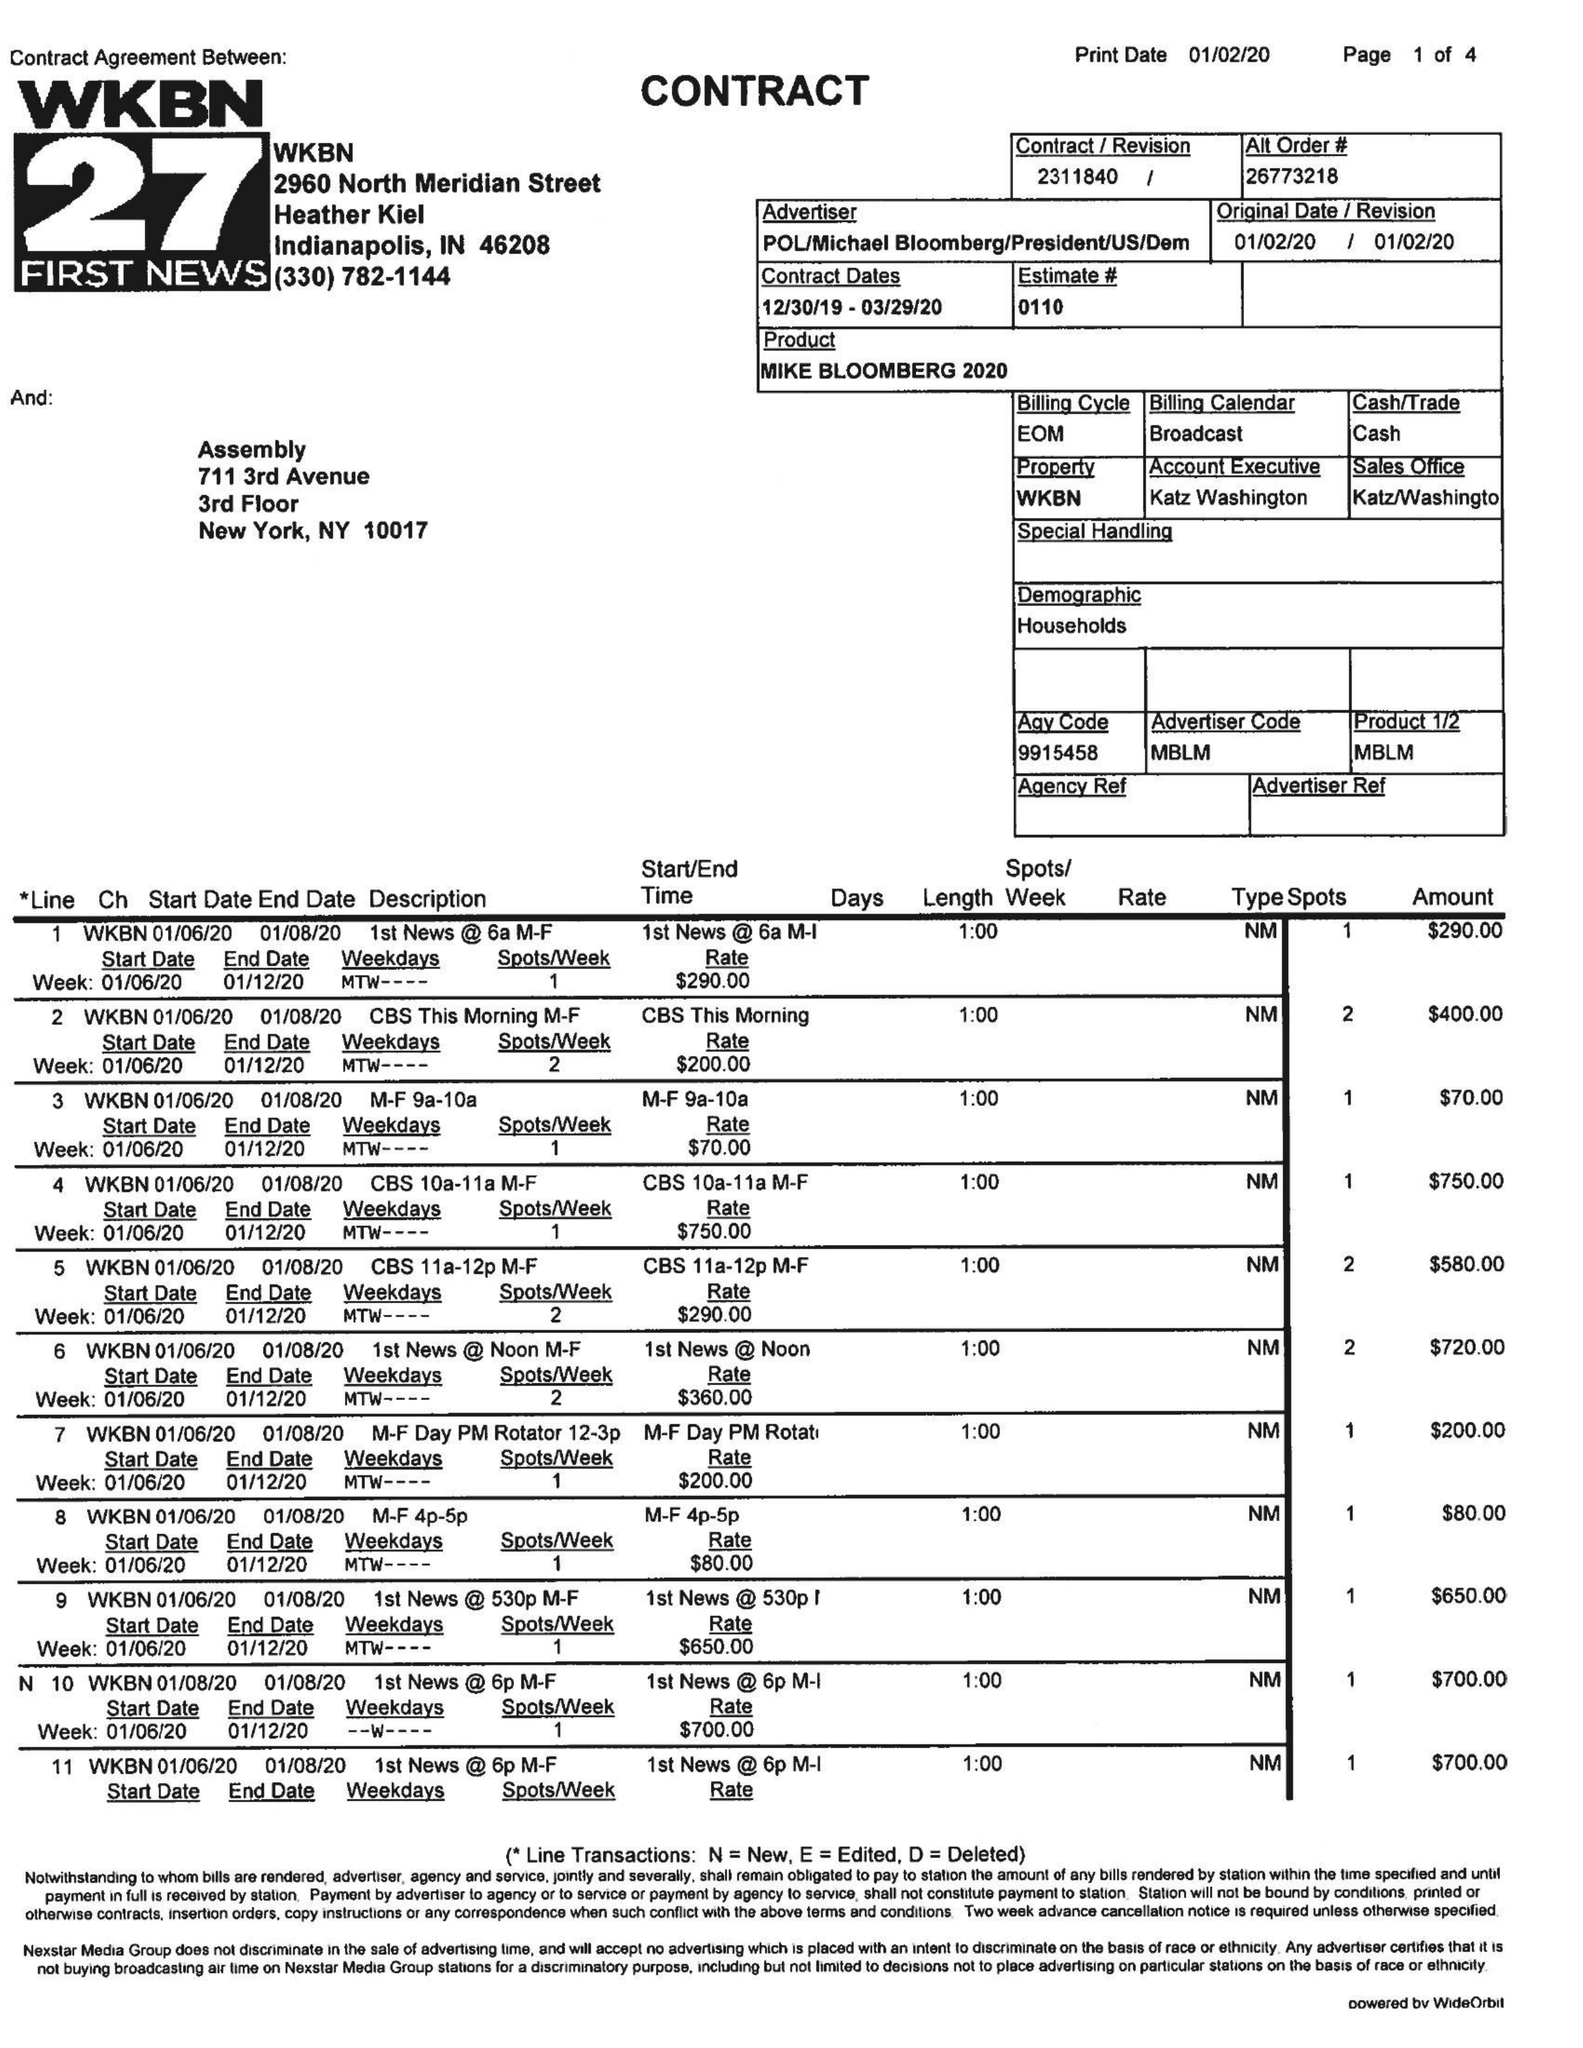What is the value for the contract_num?
Answer the question using a single word or phrase. 2311840 